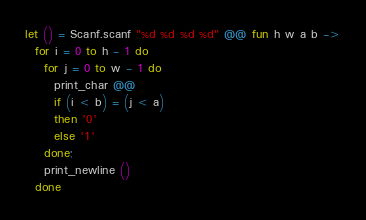<code> <loc_0><loc_0><loc_500><loc_500><_OCaml_>let () = Scanf.scanf "%d %d %d %d" @@ fun h w a b ->
  for i = 0 to h - 1 do
    for j = 0 to w - 1 do
      print_char @@
      if (i < b) = (j < a)
      then '0'
      else '1'
    done;
    print_newline ()
  done
</code> 